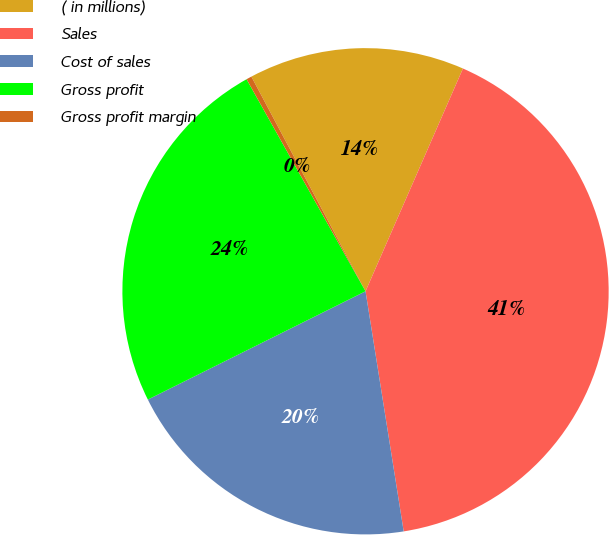Convert chart. <chart><loc_0><loc_0><loc_500><loc_500><pie_chart><fcel>( in millions)<fcel>Sales<fcel>Cost of sales<fcel>Gross profit<fcel>Gross profit margin<nl><fcel>14.34%<fcel>40.93%<fcel>20.16%<fcel>24.21%<fcel>0.36%<nl></chart> 